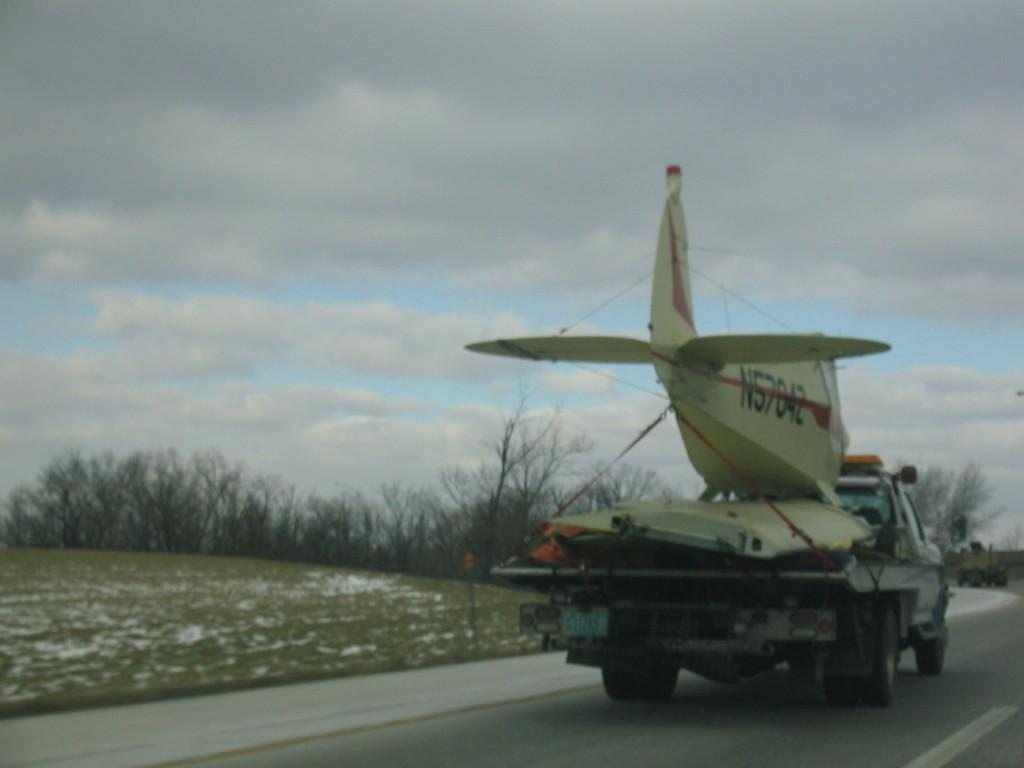What type of vehicles can be seen on the road in the image? There are vehicles on the road in the image. What type of vegetation is visible in the image? There is green grass visible in the image. What is the mode of transportation in the sky in the image? There is an aircraft in the image. What type of natural features are present in the image? There are trees in the image. What is visible in the sky in the image? Clouds are visible in the sky in the image. Where is the tray of lettuce located in the image? There is no tray of lettuce present in the image. What type of plane can be seen flying over the trees in the image? There is no plane flying over the trees in the image; it is an aircraft in the sky. 